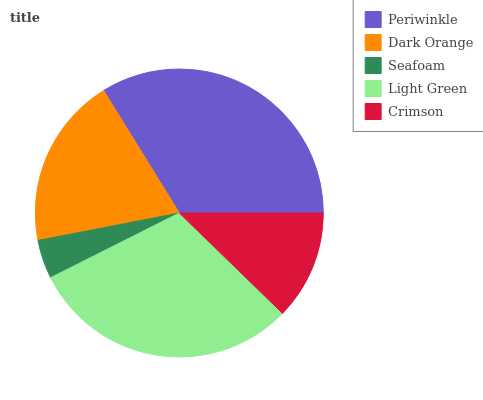Is Seafoam the minimum?
Answer yes or no. Yes. Is Periwinkle the maximum?
Answer yes or no. Yes. Is Dark Orange the minimum?
Answer yes or no. No. Is Dark Orange the maximum?
Answer yes or no. No. Is Periwinkle greater than Dark Orange?
Answer yes or no. Yes. Is Dark Orange less than Periwinkle?
Answer yes or no. Yes. Is Dark Orange greater than Periwinkle?
Answer yes or no. No. Is Periwinkle less than Dark Orange?
Answer yes or no. No. Is Dark Orange the high median?
Answer yes or no. Yes. Is Dark Orange the low median?
Answer yes or no. Yes. Is Light Green the high median?
Answer yes or no. No. Is Light Green the low median?
Answer yes or no. No. 